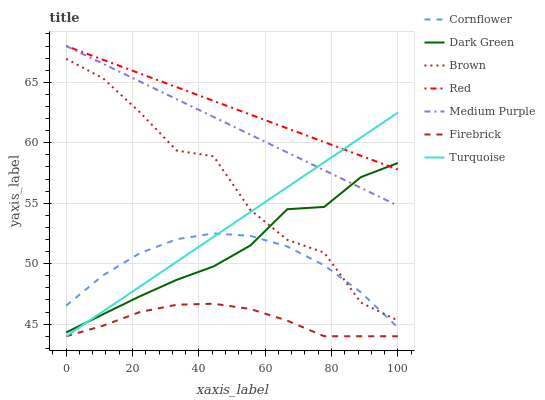Does Firebrick have the minimum area under the curve?
Answer yes or no. Yes. Does Red have the maximum area under the curve?
Answer yes or no. Yes. Does Turquoise have the minimum area under the curve?
Answer yes or no. No. Does Turquoise have the maximum area under the curve?
Answer yes or no. No. Is Turquoise the smoothest?
Answer yes or no. Yes. Is Brown the roughest?
Answer yes or no. Yes. Is Brown the smoothest?
Answer yes or no. No. Is Turquoise the roughest?
Answer yes or no. No. Does Turquoise have the lowest value?
Answer yes or no. Yes. Does Brown have the lowest value?
Answer yes or no. No. Does Red have the highest value?
Answer yes or no. Yes. Does Turquoise have the highest value?
Answer yes or no. No. Is Cornflower less than Medium Purple?
Answer yes or no. Yes. Is Red greater than Cornflower?
Answer yes or no. Yes. Does Medium Purple intersect Turquoise?
Answer yes or no. Yes. Is Medium Purple less than Turquoise?
Answer yes or no. No. Is Medium Purple greater than Turquoise?
Answer yes or no. No. Does Cornflower intersect Medium Purple?
Answer yes or no. No. 